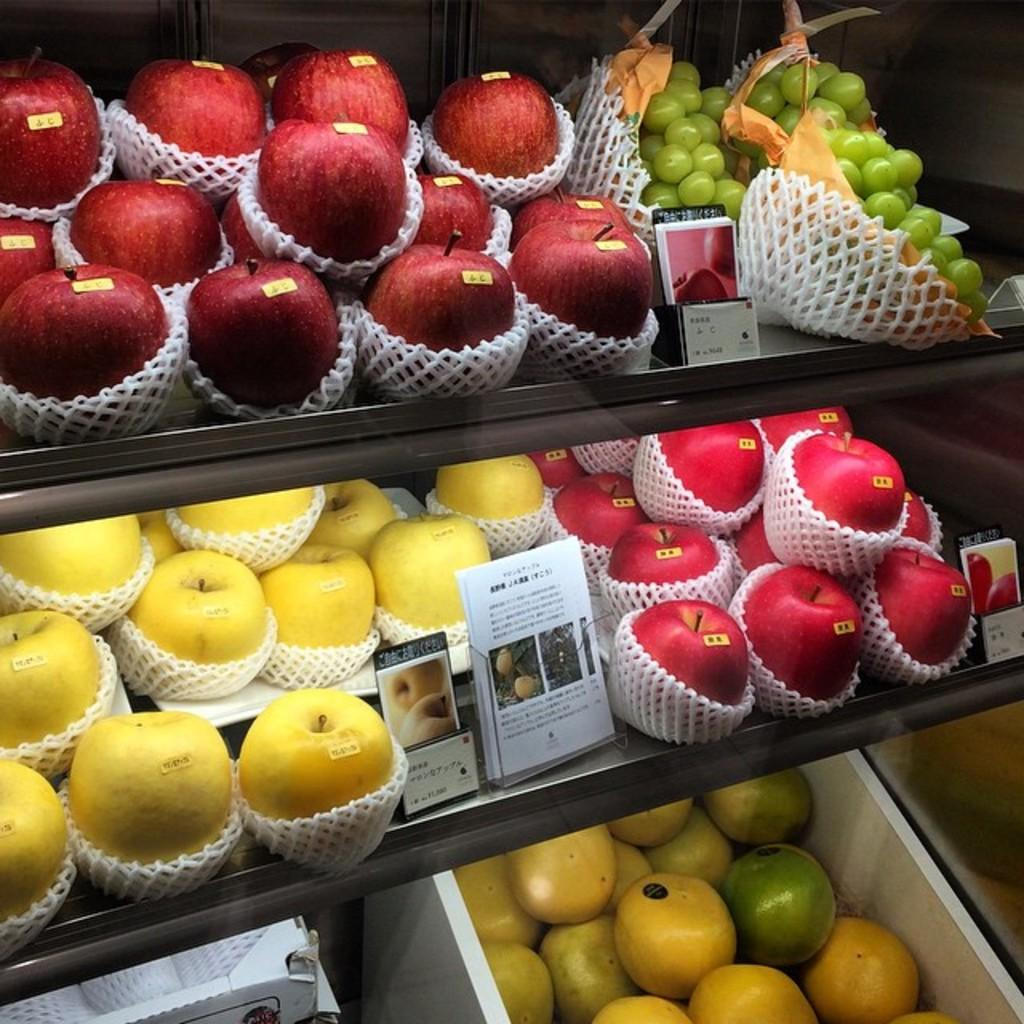What type of fruit is present in the image? There are red apples and grapes in the image. Where are the grapes located in relation to the apples? The grapes are located at the bottom of the image. What type of tool is being used by the rabbit in the image? There is no rabbit or tool present in the image. Can you describe the ball that is being bounced by the grapes in the image? There is no ball present in the image; the grapes are simply located at the bottom of the image. 